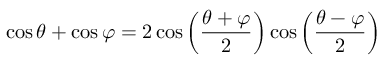Convert formula to latex. <formula><loc_0><loc_0><loc_500><loc_500>\cos \theta + \cos \varphi = 2 \cos \left ( { \frac { \theta + \varphi } { 2 } } \right ) \cos \left ( { \frac { \theta - \varphi } { 2 } } \right )</formula> 